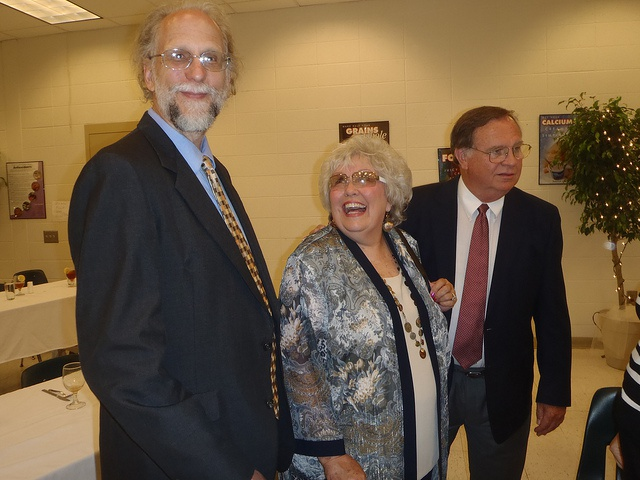Describe the objects in this image and their specific colors. I can see people in tan, black, gray, and darkgray tones, people in tan, gray, black, and darkgray tones, people in tan, black, maroon, darkgray, and brown tones, potted plant in tan, black, olive, and maroon tones, and dining table in khaki and tan tones in this image. 